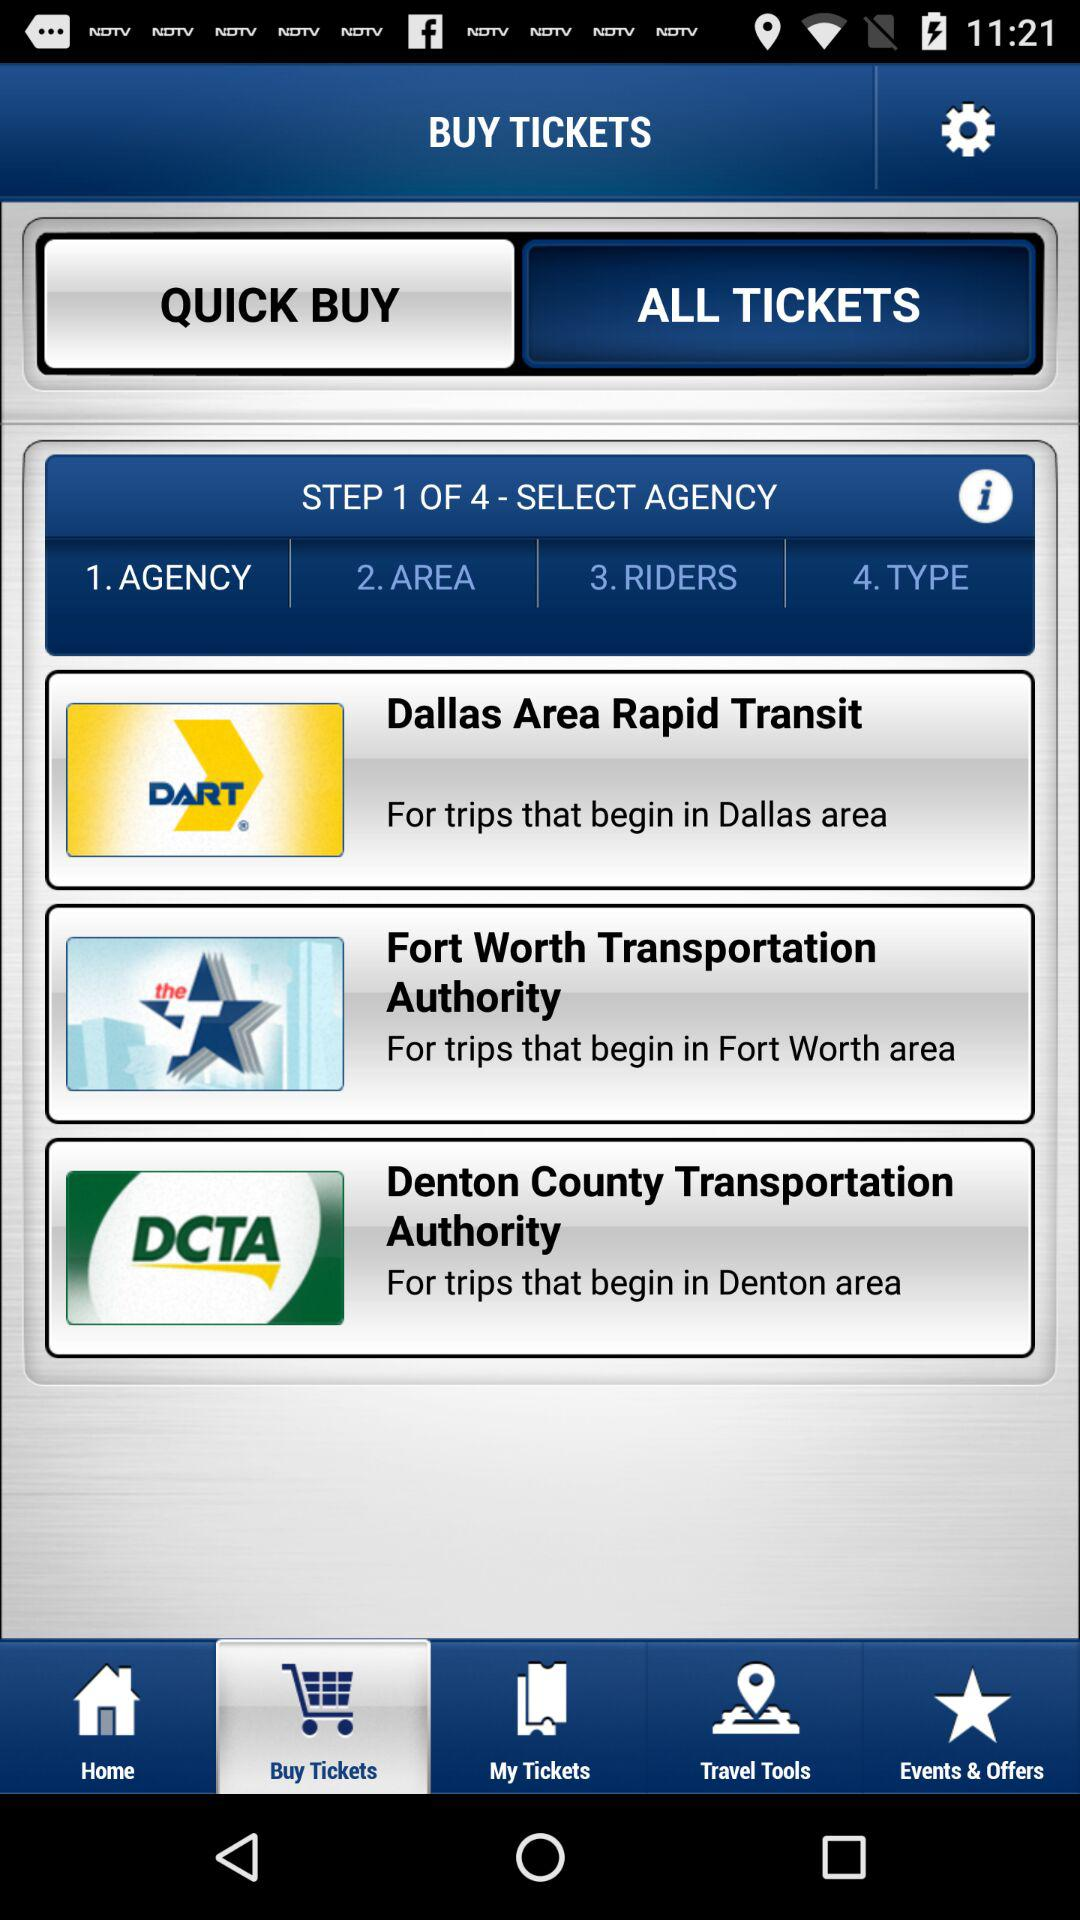How many agencies are available to select from?
Answer the question using a single word or phrase. 3 